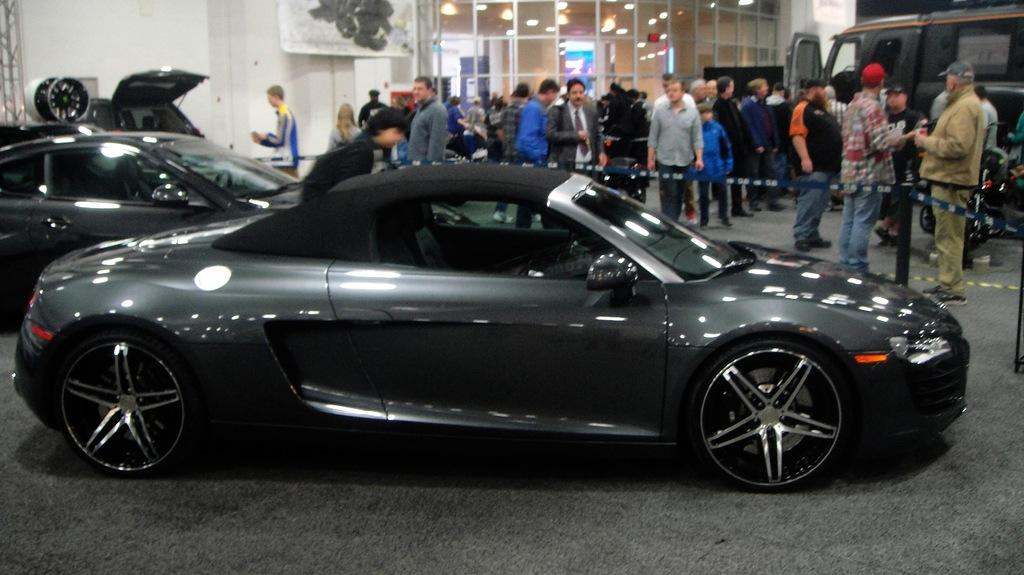What type of vehicles can be seen in the image? There are cars and a van in the image. Where is the van located in the image? The van is on the side of the image. What color are the cars in the image? The cars are black in color. Are there any people present in the image? Yes, there are people standing in the image. Can you tell me how many snails are crawling on the van in the image? There are no snails present in the image; it only features cars, a van, and people. What type of clam is being offered to the people in the image? There is no clam or any food being offered in the image. 